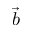Convert formula to latex. <formula><loc_0><loc_0><loc_500><loc_500>\ V e c { b }</formula> 